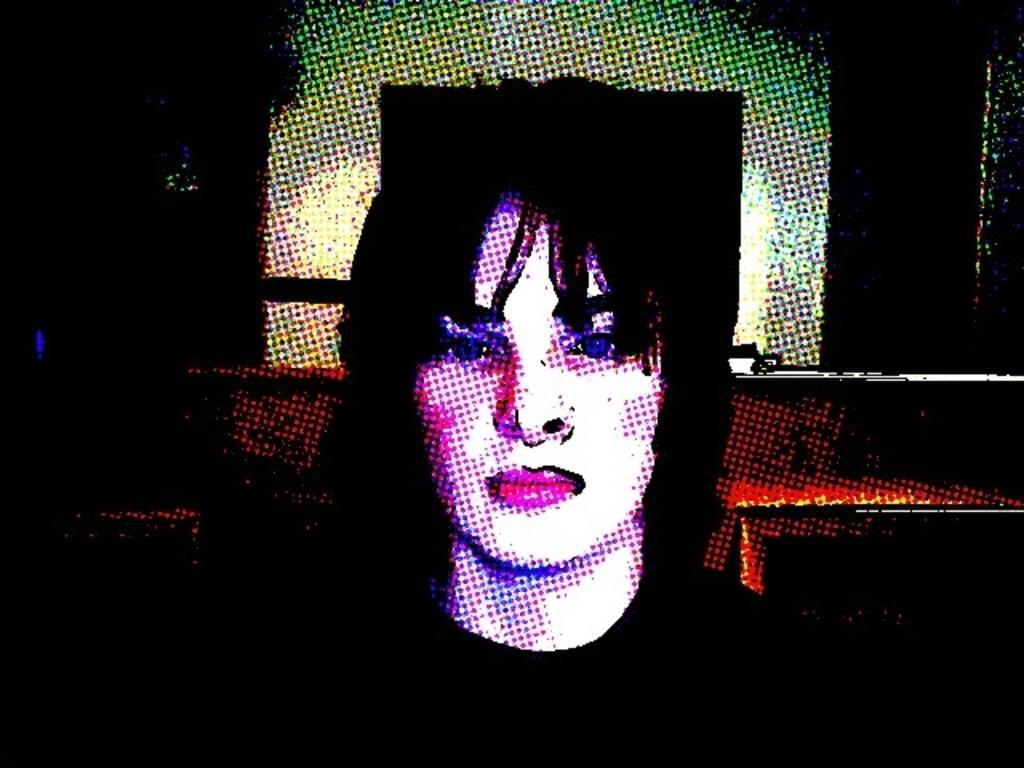Who or what is present in the image? There is a person in the image. What can be observed about the background of the image? The background of the image is dark. How many horses are visible in the image? There are no horses present in the image. What direction is the person walking in the image? The image does not show the person walking, so it cannot be determined which way they might be going. 